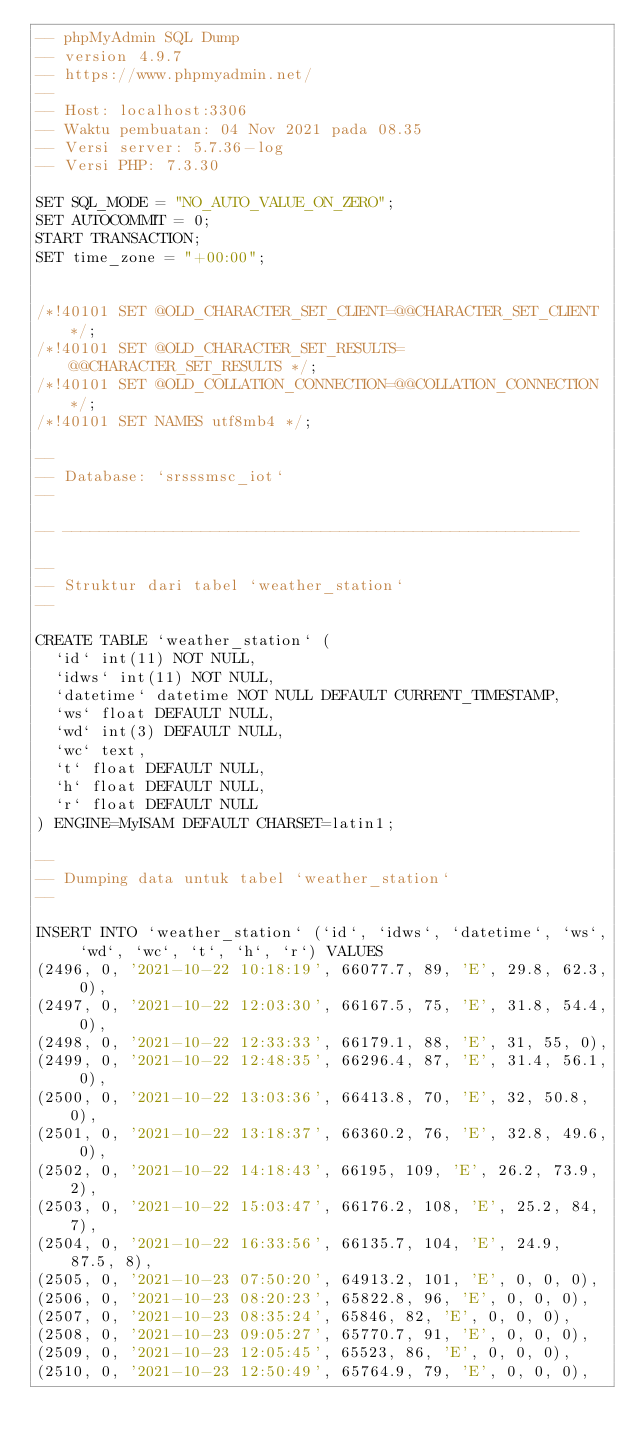Convert code to text. <code><loc_0><loc_0><loc_500><loc_500><_SQL_>-- phpMyAdmin SQL Dump
-- version 4.9.7
-- https://www.phpmyadmin.net/
--
-- Host: localhost:3306
-- Waktu pembuatan: 04 Nov 2021 pada 08.35
-- Versi server: 5.7.36-log
-- Versi PHP: 7.3.30

SET SQL_MODE = "NO_AUTO_VALUE_ON_ZERO";
SET AUTOCOMMIT = 0;
START TRANSACTION;
SET time_zone = "+00:00";


/*!40101 SET @OLD_CHARACTER_SET_CLIENT=@@CHARACTER_SET_CLIENT */;
/*!40101 SET @OLD_CHARACTER_SET_RESULTS=@@CHARACTER_SET_RESULTS */;
/*!40101 SET @OLD_COLLATION_CONNECTION=@@COLLATION_CONNECTION */;
/*!40101 SET NAMES utf8mb4 */;

--
-- Database: `srsssmsc_iot`
--

-- --------------------------------------------------------

--
-- Struktur dari tabel `weather_station`
--

CREATE TABLE `weather_station` (
  `id` int(11) NOT NULL,
  `idws` int(11) NOT NULL,
  `datetime` datetime NOT NULL DEFAULT CURRENT_TIMESTAMP,
  `ws` float DEFAULT NULL,
  `wd` int(3) DEFAULT NULL,
  `wc` text,
  `t` float DEFAULT NULL,
  `h` float DEFAULT NULL,
  `r` float DEFAULT NULL
) ENGINE=MyISAM DEFAULT CHARSET=latin1;

--
-- Dumping data untuk tabel `weather_station`
--

INSERT INTO `weather_station` (`id`, `idws`, `datetime`, `ws`, `wd`, `wc`, `t`, `h`, `r`) VALUES
(2496, 0, '2021-10-22 10:18:19', 66077.7, 89, 'E', 29.8, 62.3, 0),
(2497, 0, '2021-10-22 12:03:30', 66167.5, 75, 'E', 31.8, 54.4, 0),
(2498, 0, '2021-10-22 12:33:33', 66179.1, 88, 'E', 31, 55, 0),
(2499, 0, '2021-10-22 12:48:35', 66296.4, 87, 'E', 31.4, 56.1, 0),
(2500, 0, '2021-10-22 13:03:36', 66413.8, 70, 'E', 32, 50.8, 0),
(2501, 0, '2021-10-22 13:18:37', 66360.2, 76, 'E', 32.8, 49.6, 0),
(2502, 0, '2021-10-22 14:18:43', 66195, 109, 'E', 26.2, 73.9, 2),
(2503, 0, '2021-10-22 15:03:47', 66176.2, 108, 'E', 25.2, 84, 7),
(2504, 0, '2021-10-22 16:33:56', 66135.7, 104, 'E', 24.9, 87.5, 8),
(2505, 0, '2021-10-23 07:50:20', 64913.2, 101, 'E', 0, 0, 0),
(2506, 0, '2021-10-23 08:20:23', 65822.8, 96, 'E', 0, 0, 0),
(2507, 0, '2021-10-23 08:35:24', 65846, 82, 'E', 0, 0, 0),
(2508, 0, '2021-10-23 09:05:27', 65770.7, 91, 'E', 0, 0, 0),
(2509, 0, '2021-10-23 12:05:45', 65523, 86, 'E', 0, 0, 0),
(2510, 0, '2021-10-23 12:50:49', 65764.9, 79, 'E', 0, 0, 0),</code> 